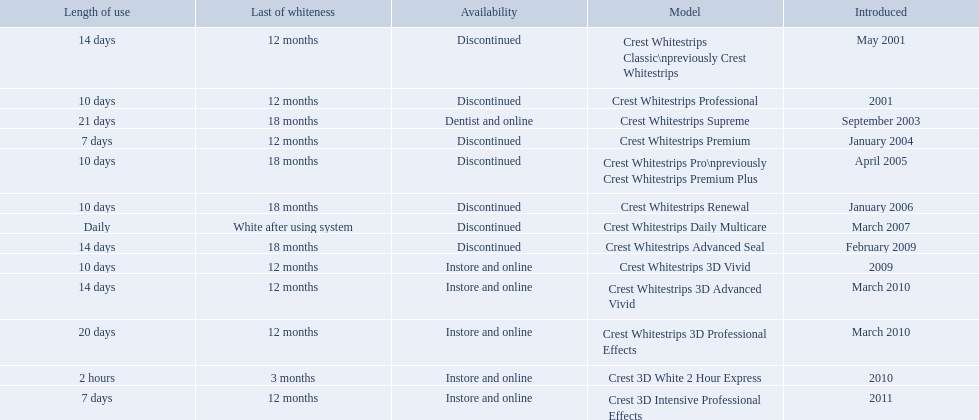What types of crest whitestrips have been released? Crest Whitestrips Classic\npreviously Crest Whitestrips, Crest Whitestrips Professional, Crest Whitestrips Supreme, Crest Whitestrips Premium, Crest Whitestrips Pro\npreviously Crest Whitestrips Premium Plus, Crest Whitestrips Renewal, Crest Whitestrips Daily Multicare, Crest Whitestrips Advanced Seal, Crest Whitestrips 3D Vivid, Crest Whitestrips 3D Advanced Vivid, Crest Whitestrips 3D Professional Effects, Crest 3D White 2 Hour Express, Crest 3D Intensive Professional Effects. What was the length of use for each type? 14 days, 10 days, 21 days, 7 days, 10 days, 10 days, Daily, 14 days, 10 days, 14 days, 20 days, 2 hours, 7 days. And how long did each last? 12 months, 12 months, 18 months, 12 months, 18 months, 18 months, White after using system, 18 months, 12 months, 12 months, 12 months, 3 months, 12 months. Of those models, which lasted the longest with the longest length of use? Crest Whitestrips Supreme. What are all the models? Crest Whitestrips Classic\npreviously Crest Whitestrips, Crest Whitestrips Professional, Crest Whitestrips Supreme, Crest Whitestrips Premium, Crest Whitestrips Pro\npreviously Crest Whitestrips Premium Plus, Crest Whitestrips Renewal, Crest Whitestrips Daily Multicare, Crest Whitestrips Advanced Seal, Crest Whitestrips 3D Vivid, Crest Whitestrips 3D Advanced Vivid, Crest Whitestrips 3D Professional Effects, Crest 3D White 2 Hour Express, Crest 3D Intensive Professional Effects. Of these, for which can a ratio be calculated for 'length of use' to 'last of whiteness'? Crest Whitestrips Classic\npreviously Crest Whitestrips, Crest Whitestrips Professional, Crest Whitestrips Supreme, Crest Whitestrips Premium, Crest Whitestrips Pro\npreviously Crest Whitestrips Premium Plus, Crest Whitestrips Renewal, Crest Whitestrips Advanced Seal, Crest Whitestrips 3D Vivid, Crest Whitestrips 3D Advanced Vivid, Crest Whitestrips 3D Professional Effects, Crest 3D White 2 Hour Express, Crest 3D Intensive Professional Effects. Which has the highest ratio? Crest Whitestrips Supreme. When was crest whitestrips 3d advanced vivid introduced? March 2010. What other product was introduced in march 2010? Crest Whitestrips 3D Professional Effects. Could you parse the entire table? {'header': ['Length of use', 'Last of whiteness', 'Availability', 'Model', 'Introduced'], 'rows': [['14 days', '12 months', 'Discontinued', 'Crest Whitestrips Classic\\npreviously Crest Whitestrips', 'May 2001'], ['10 days', '12 months', 'Discontinued', 'Crest Whitestrips Professional', '2001'], ['21 days', '18 months', 'Dentist and online', 'Crest Whitestrips Supreme', 'September 2003'], ['7 days', '12 months', 'Discontinued', 'Crest Whitestrips Premium', 'January 2004'], ['10 days', '18 months', 'Discontinued', 'Crest Whitestrips Pro\\npreviously Crest Whitestrips Premium Plus', 'April 2005'], ['10 days', '18 months', 'Discontinued', 'Crest Whitestrips Renewal', 'January 2006'], ['Daily', 'White after using system', 'Discontinued', 'Crest Whitestrips Daily Multicare', 'March 2007'], ['14 days', '18 months', 'Discontinued', 'Crest Whitestrips Advanced Seal', 'February 2009'], ['10 days', '12 months', 'Instore and online', 'Crest Whitestrips 3D Vivid', '2009'], ['14 days', '12 months', 'Instore and online', 'Crest Whitestrips 3D Advanced Vivid', 'March 2010'], ['20 days', '12 months', 'Instore and online', 'Crest Whitestrips 3D Professional Effects', 'March 2010'], ['2 hours', '3 months', 'Instore and online', 'Crest 3D White 2 Hour Express', '2010'], ['7 days', '12 months', 'Instore and online', 'Crest 3D Intensive Professional Effects', '2011']]} 